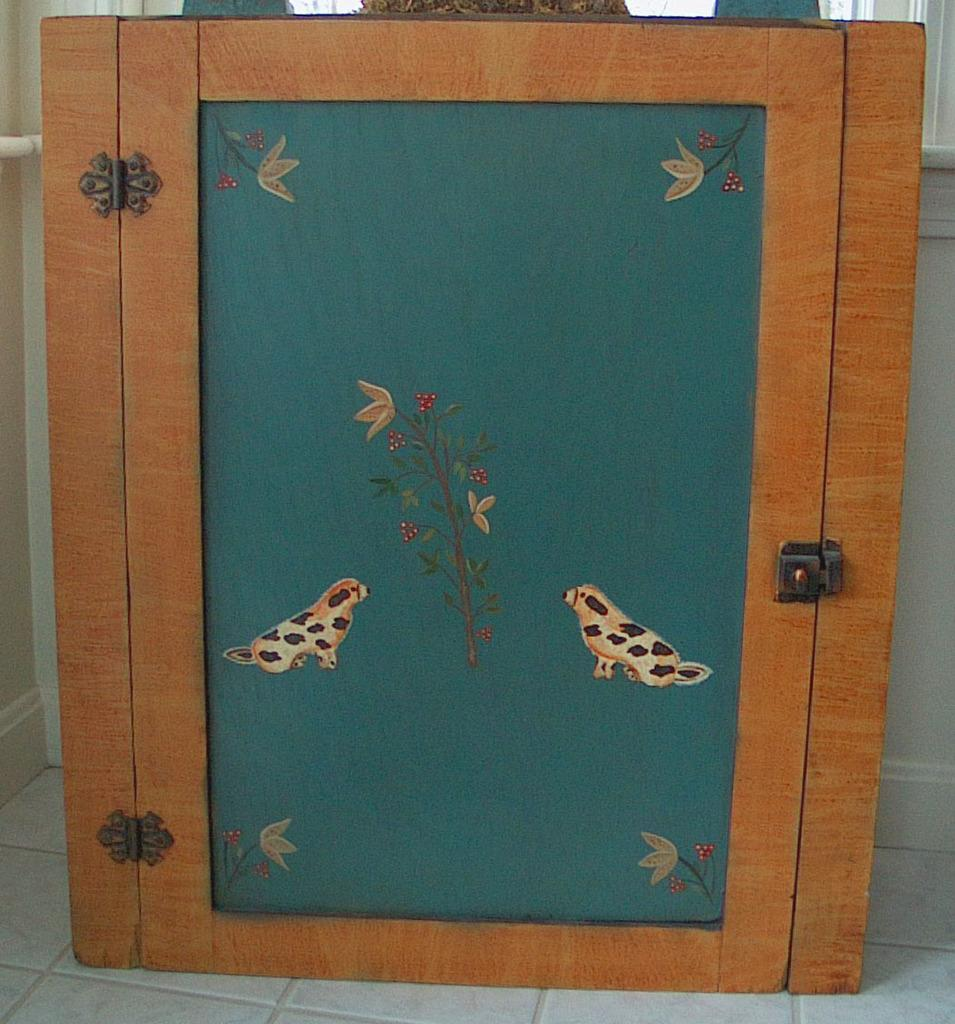What type of object is in the image? There is a wooden box in the image. What feature does the wooden box have? The wooden box has a door. What can be seen on the door of the wooden box? There is a painting on the door of the wooden box. How many sheep are visible in the painting on the door of the wooden box? There are no sheep present in the image, as the painting on the door of the wooden box is not described in the provided facts. 